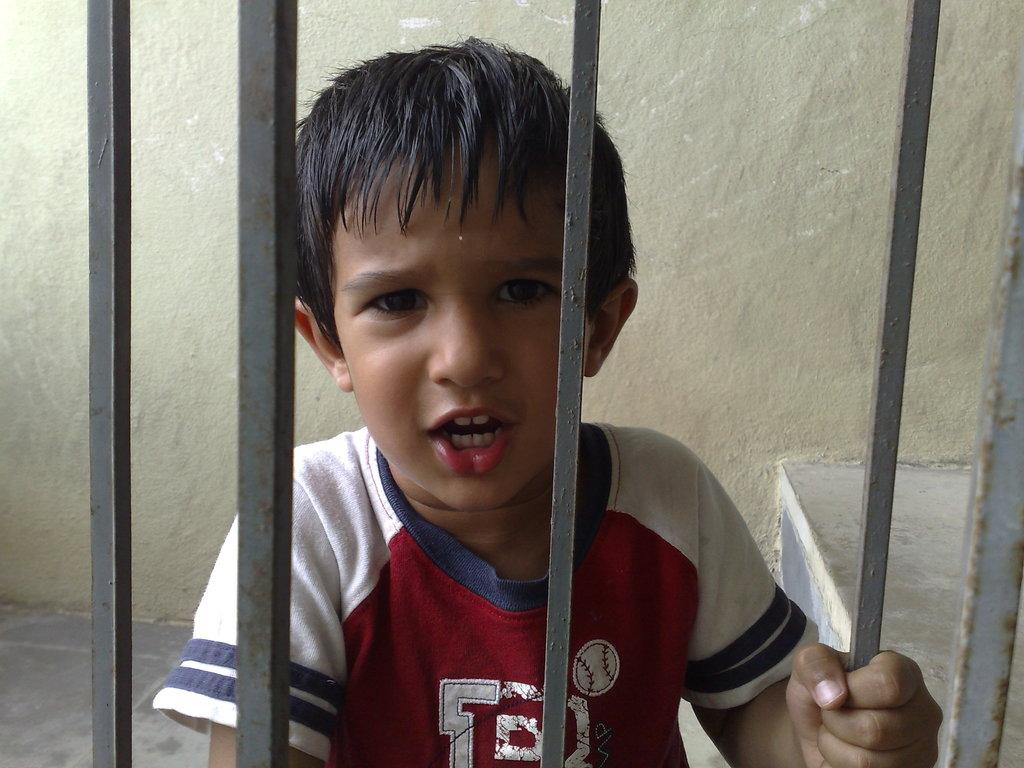Who is present in the image? There is a boy in the image. What is the boy's position in relation to the metal rods? The boy is behind metal rods. What can be seen behind the boy? There is a wall visible behind the boy. What type of brick is the boy using to build a structure in the image? There is no brick or structure-building activity present in the image. How many noses can be seen on the boy's face in the image? The boy has one nose, as is typical for human beings. 